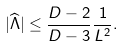<formula> <loc_0><loc_0><loc_500><loc_500>| { \widehat { \Lambda } } | \leq { \frac { D - 2 } { D - 3 } } { \frac { 1 } { L ^ { 2 } } } .</formula> 